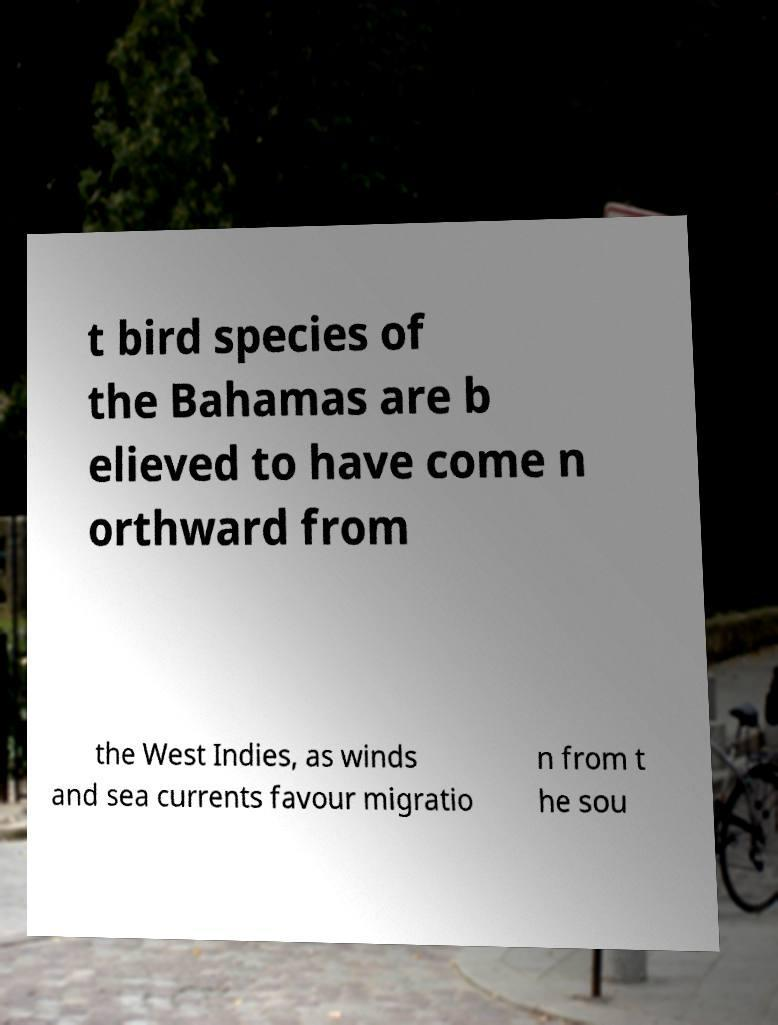Please read and relay the text visible in this image. What does it say? t bird species of the Bahamas are b elieved to have come n orthward from the West Indies, as winds and sea currents favour migratio n from t he sou 